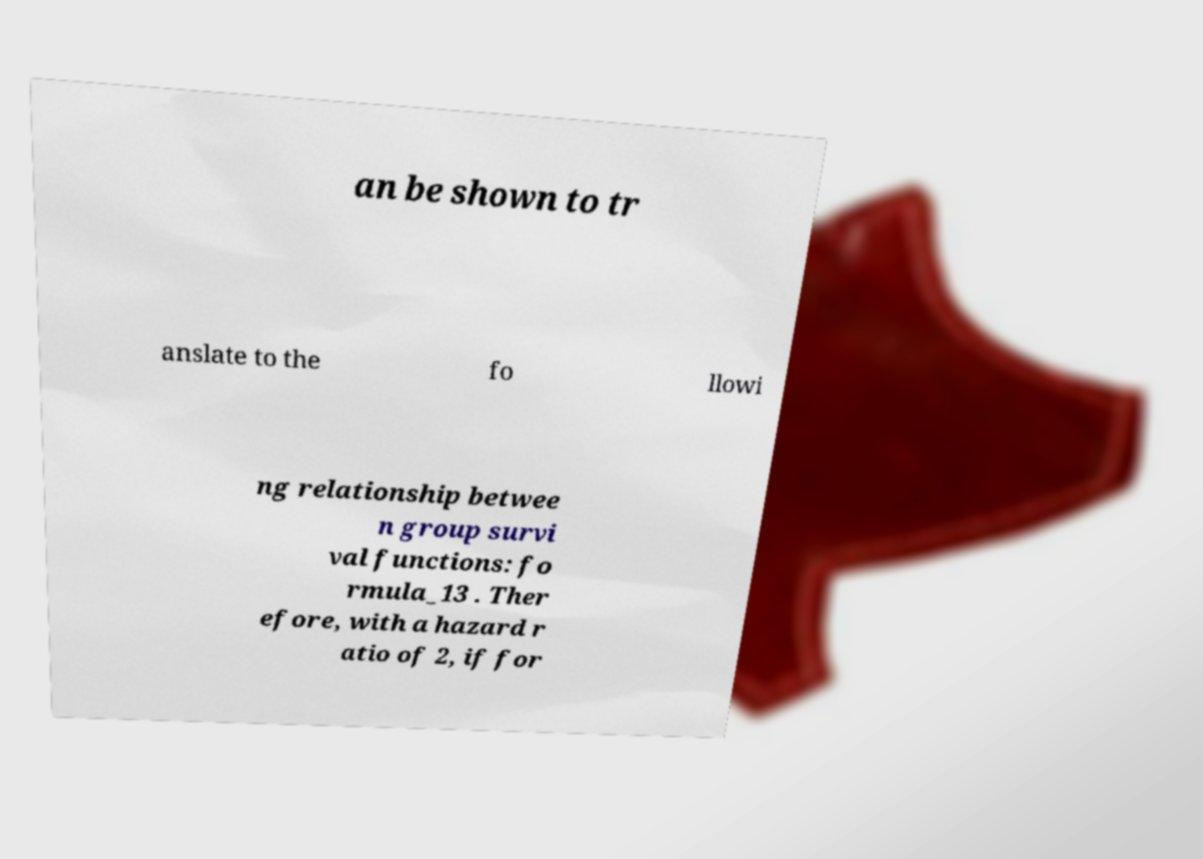Can you read and provide the text displayed in the image?This photo seems to have some interesting text. Can you extract and type it out for me? an be shown to tr anslate to the fo llowi ng relationship betwee n group survi val functions: fo rmula_13 . Ther efore, with a hazard r atio of 2, if for 